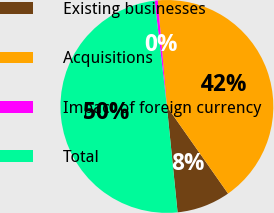<chart> <loc_0><loc_0><loc_500><loc_500><pie_chart><fcel>Existing businesses<fcel>Acquisitions<fcel>Impact of foreign currency<fcel>Total<nl><fcel>8.14%<fcel>41.62%<fcel>0.47%<fcel>49.76%<nl></chart> 